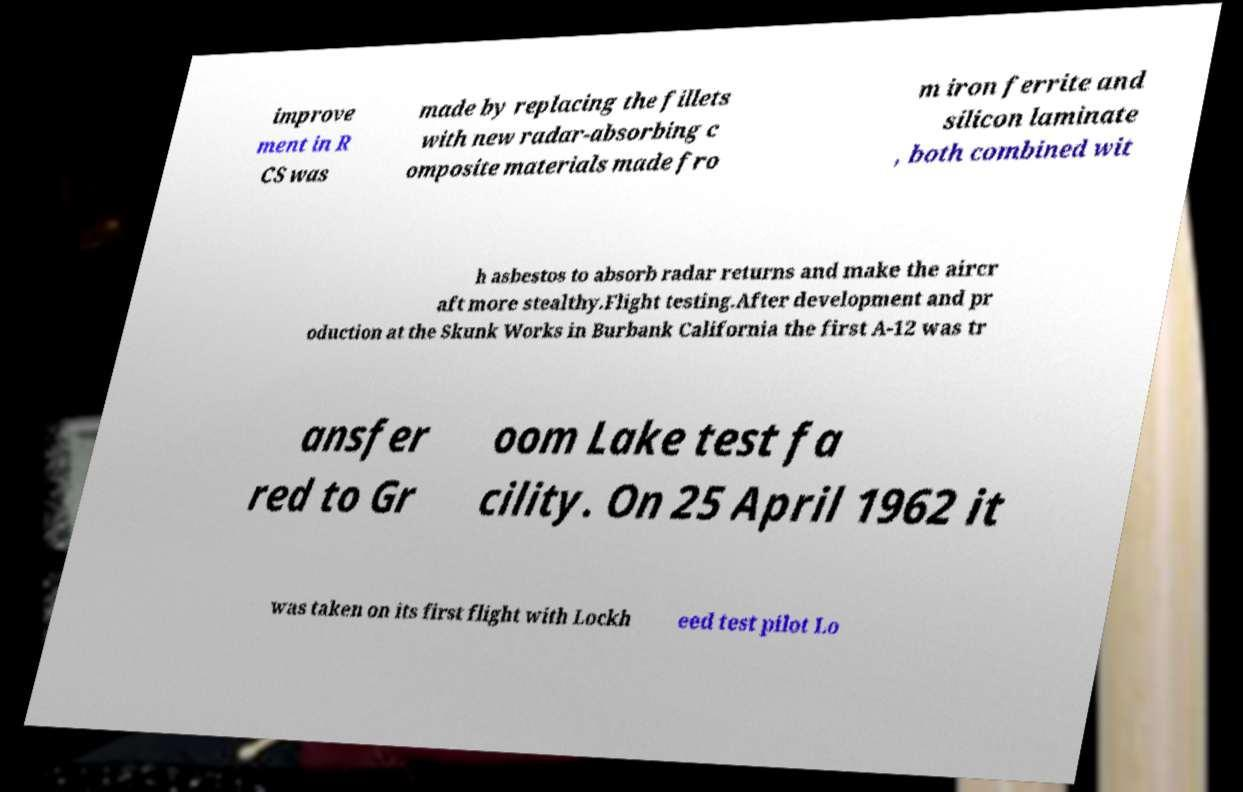Can you accurately transcribe the text from the provided image for me? improve ment in R CS was made by replacing the fillets with new radar-absorbing c omposite materials made fro m iron ferrite and silicon laminate , both combined wit h asbestos to absorb radar returns and make the aircr aft more stealthy.Flight testing.After development and pr oduction at the Skunk Works in Burbank California the first A-12 was tr ansfer red to Gr oom Lake test fa cility. On 25 April 1962 it was taken on its first flight with Lockh eed test pilot Lo 